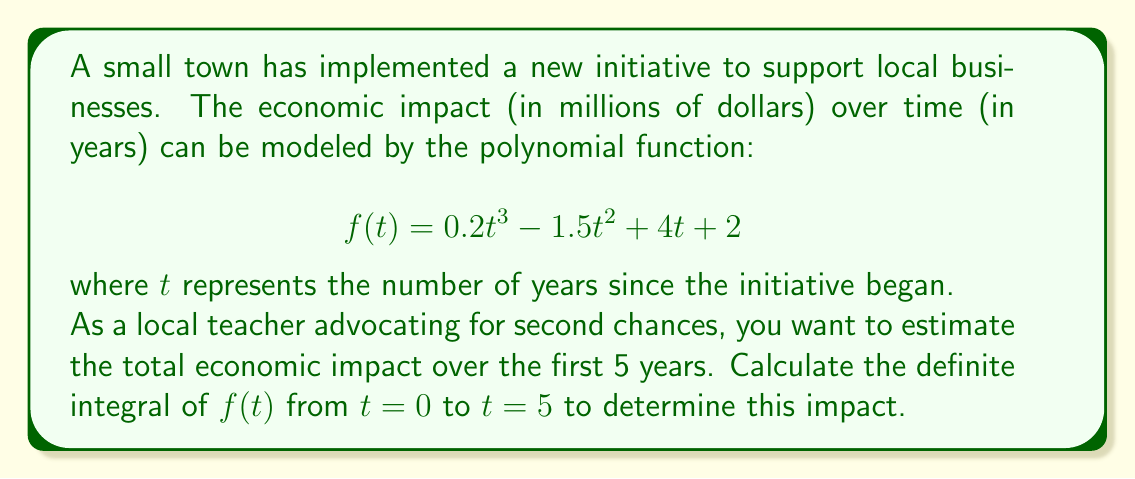Give your solution to this math problem. To solve this problem, we need to follow these steps:

1) The function given is $f(t) = 0.2t^3 - 1.5t^2 + 4t + 2$

2) To find the total economic impact over 5 years, we need to calculate the definite integral from 0 to 5:

   $$\int_0^5 (0.2t^3 - 1.5t^2 + 4t + 2) dt$$

3) Let's integrate each term:
   
   $$\int 0.2t^3 dt = 0.05t^4$$
   $$\int -1.5t^2 dt = -0.5t^3$$
   $$\int 4t dt = 2t^2$$
   $$\int 2 dt = 2t$$

4) Now our integral becomes:

   $$[0.05t^4 - 0.5t^3 + 2t^2 + 2t]_0^5$$

5) Let's evaluate this at t=5 and t=0:

   At t=5: $0.05(5^4) - 0.5(5^3) + 2(5^2) + 2(5) = 312.5 - 312.5 + 50 + 10 = 60$
   
   At t=0: $0.05(0^4) - 0.5(0^3) + 2(0^2) + 2(0) = 0$

6) The definite integral is the difference between these values:

   $60 - 0 = 60$

Therefore, the total economic impact over the first 5 years is 60 million dollars.
Answer: $60 million 